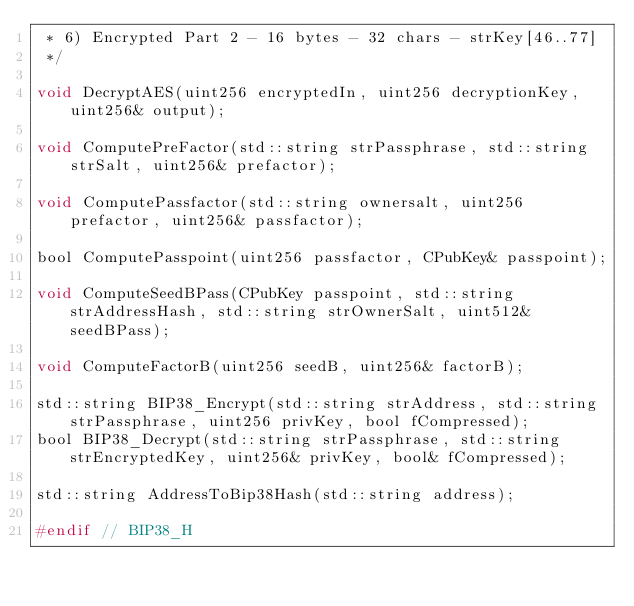Convert code to text. <code><loc_0><loc_0><loc_500><loc_500><_C_> * 6) Encrypted Part 2 - 16 bytes - 32 chars - strKey[46..77]
 */

void DecryptAES(uint256 encryptedIn, uint256 decryptionKey, uint256& output);

void ComputePreFactor(std::string strPassphrase, std::string strSalt, uint256& prefactor);

void ComputePassfactor(std::string ownersalt, uint256 prefactor, uint256& passfactor);

bool ComputePasspoint(uint256 passfactor, CPubKey& passpoint);

void ComputeSeedBPass(CPubKey passpoint, std::string strAddressHash, std::string strOwnerSalt, uint512& seedBPass);

void ComputeFactorB(uint256 seedB, uint256& factorB);

std::string BIP38_Encrypt(std::string strAddress, std::string strPassphrase, uint256 privKey, bool fCompressed);
bool BIP38_Decrypt(std::string strPassphrase, std::string strEncryptedKey, uint256& privKey, bool& fCompressed);

std::string AddressToBip38Hash(std::string address);

#endif // BIP38_H
</code> 